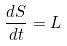<formula> <loc_0><loc_0><loc_500><loc_500>\frac { d S } { d t } = L</formula> 